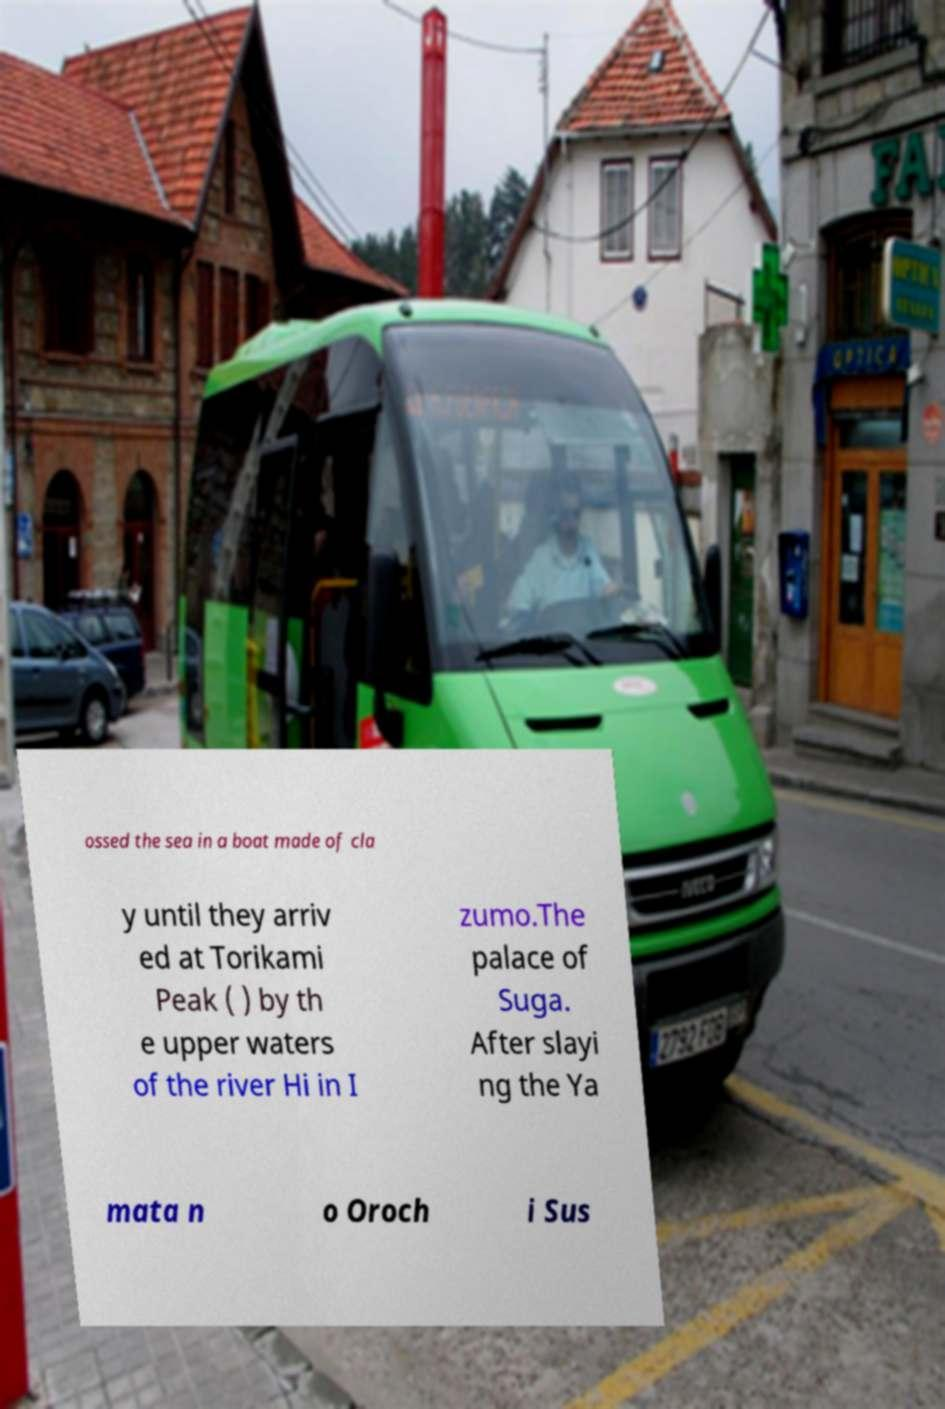Can you accurately transcribe the text from the provided image for me? ossed the sea in a boat made of cla y until they arriv ed at Torikami Peak ( ) by th e upper waters of the river Hi in I zumo.The palace of Suga. After slayi ng the Ya mata n o Oroch i Sus 